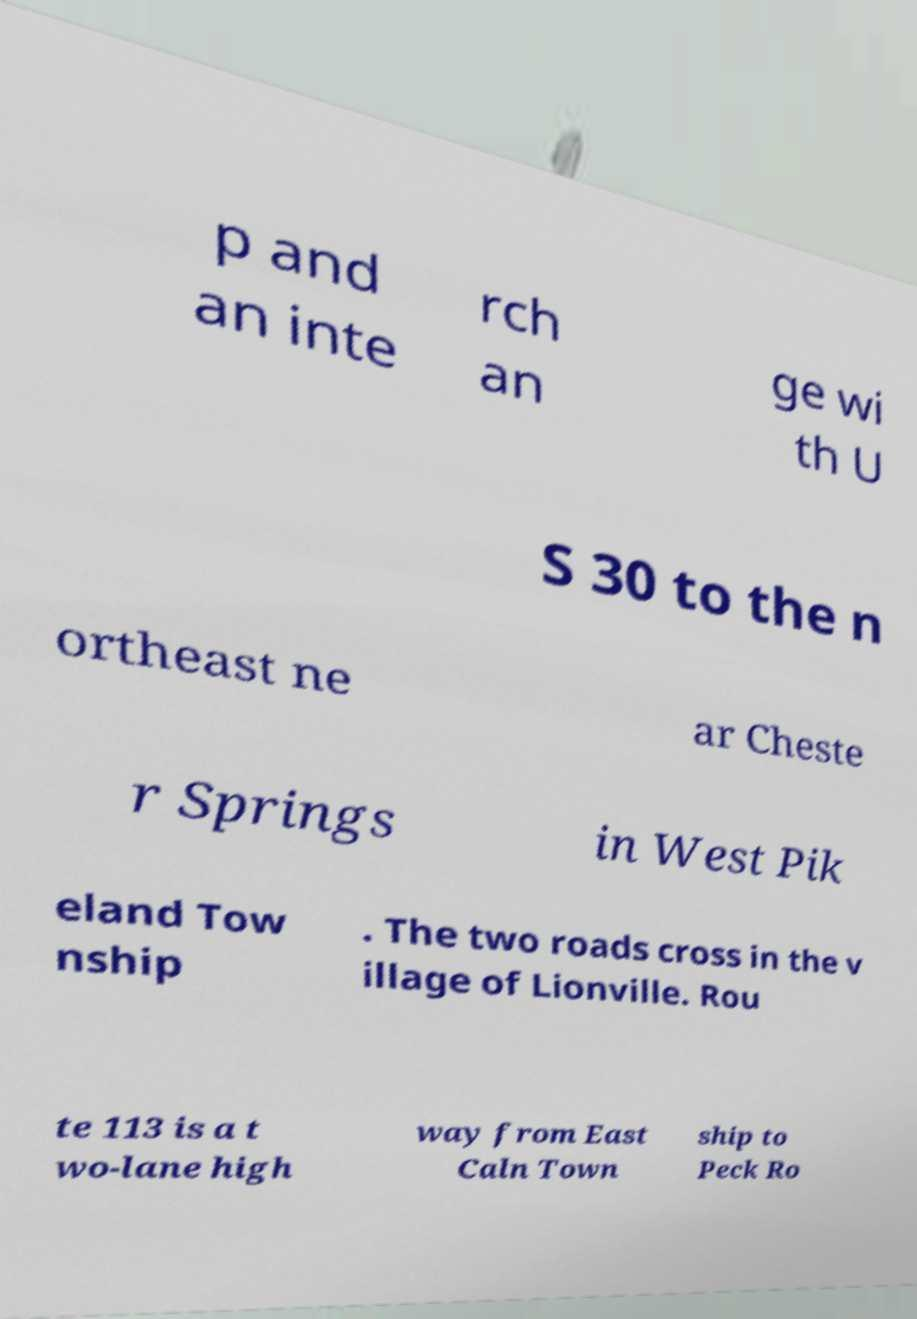Can you accurately transcribe the text from the provided image for me? p and an inte rch an ge wi th U S 30 to the n ortheast ne ar Cheste r Springs in West Pik eland Tow nship . The two roads cross in the v illage of Lionville. Rou te 113 is a t wo-lane high way from East Caln Town ship to Peck Ro 